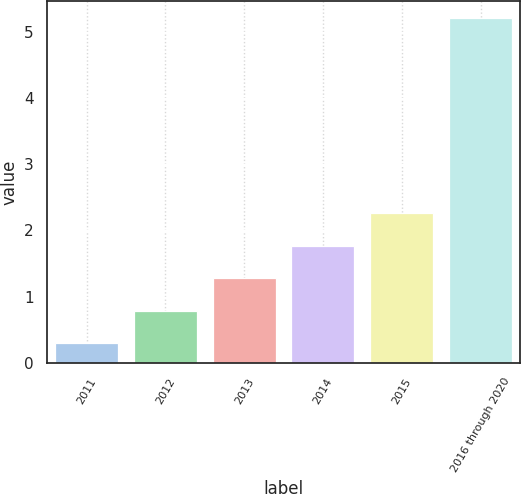Convert chart. <chart><loc_0><loc_0><loc_500><loc_500><bar_chart><fcel>2011<fcel>2012<fcel>2013<fcel>2014<fcel>2015<fcel>2016 through 2020<nl><fcel>0.3<fcel>0.79<fcel>1.28<fcel>1.77<fcel>2.26<fcel>5.2<nl></chart> 